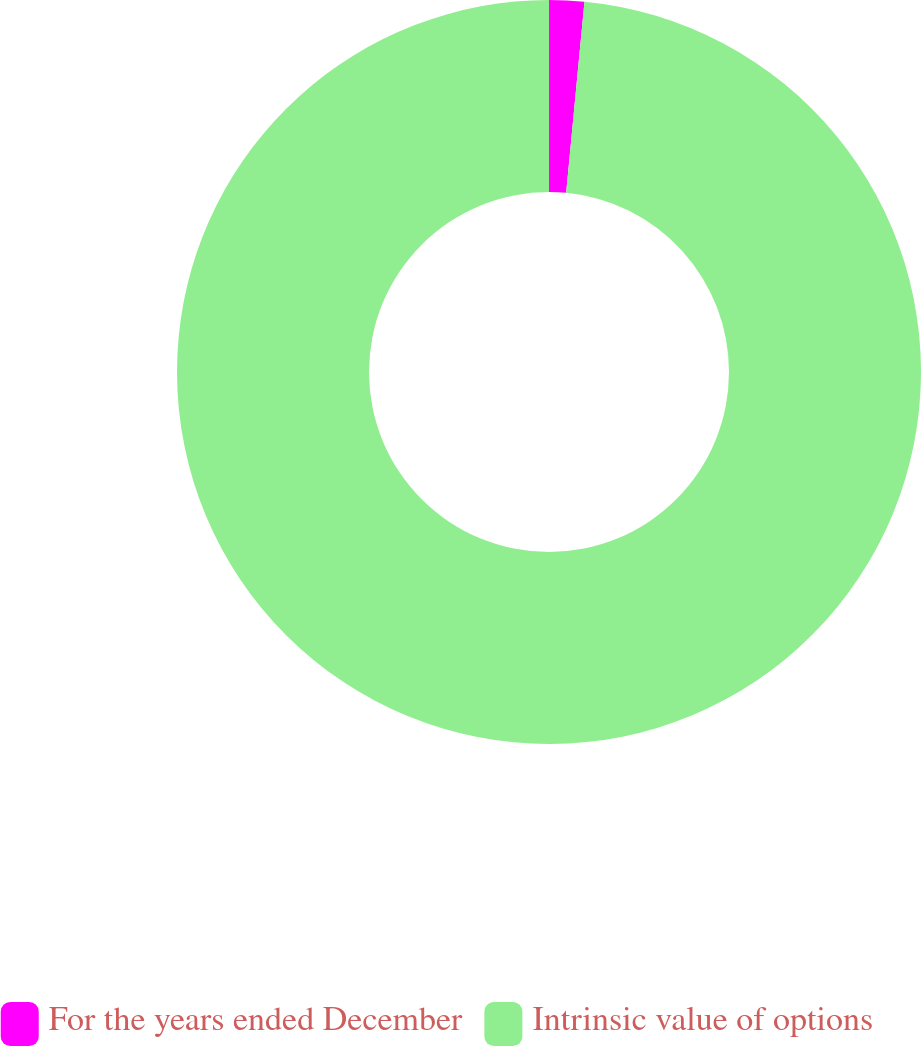Convert chart. <chart><loc_0><loc_0><loc_500><loc_500><pie_chart><fcel>For the years ended December<fcel>Intrinsic value of options<nl><fcel>1.52%<fcel>98.48%<nl></chart> 